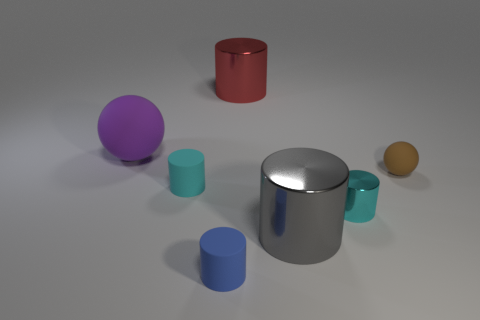What color is the metal object that is both to the left of the small cyan shiny thing and in front of the tiny matte ball?
Offer a terse response. Gray. There is a brown object that is the same size as the blue cylinder; what shape is it?
Keep it short and to the point. Sphere. Is there a small rubber object that has the same color as the big sphere?
Make the answer very short. No. Is the number of purple balls that are in front of the gray object the same as the number of cyan rubber objects?
Your response must be concise. No. Do the large matte sphere and the small matte sphere have the same color?
Make the answer very short. No. There is a metal cylinder that is both left of the cyan metal object and to the right of the big red cylinder; what size is it?
Ensure brevity in your answer.  Large. What is the color of the large object that is the same material as the brown ball?
Your response must be concise. Purple. How many brown spheres are made of the same material as the purple sphere?
Your answer should be very brief. 1. Is the number of big gray objects that are on the right side of the cyan rubber object the same as the number of cyan cylinders that are behind the small shiny object?
Your answer should be compact. Yes. Does the brown thing have the same shape as the large metal thing on the left side of the big gray object?
Your answer should be very brief. No. 